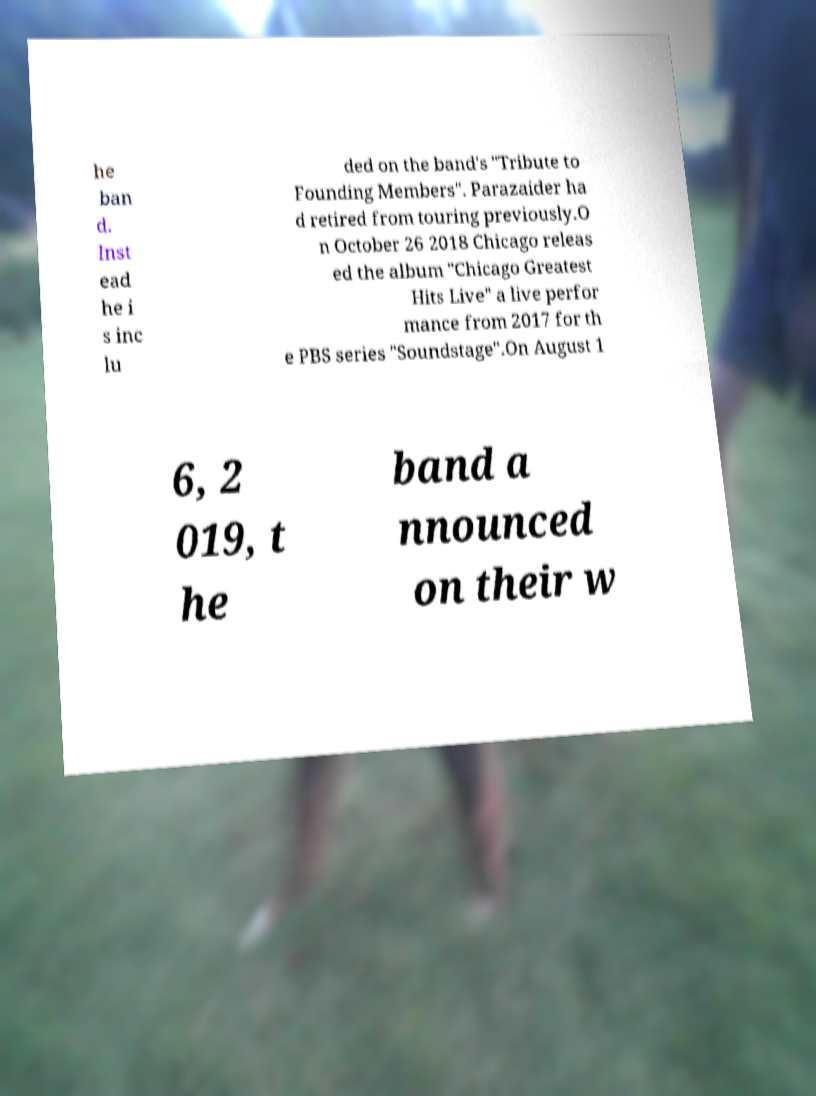Please identify and transcribe the text found in this image. he ban d. Inst ead he i s inc lu ded on the band's "Tribute to Founding Members". Parazaider ha d retired from touring previously.O n October 26 2018 Chicago releas ed the album "Chicago Greatest Hits Live" a live perfor mance from 2017 for th e PBS series "Soundstage".On August 1 6, 2 019, t he band a nnounced on their w 